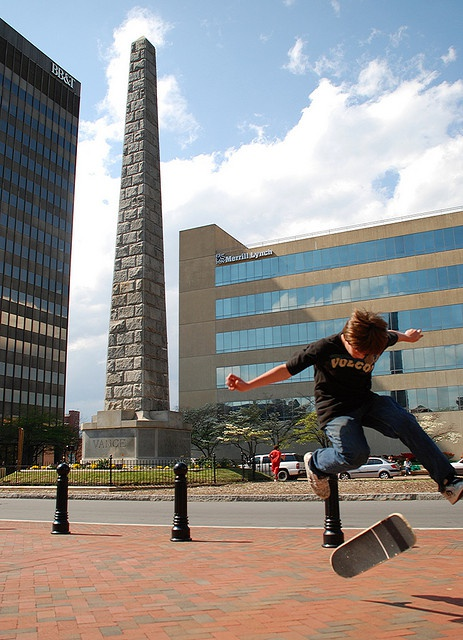Describe the objects in this image and their specific colors. I can see people in lightblue, black, gray, maroon, and brown tones, skateboard in lightblue, black, and gray tones, car in lightblue, black, white, gray, and darkgray tones, truck in lightblue, black, white, darkgray, and gray tones, and car in lightblue, darkgray, black, and gray tones in this image. 